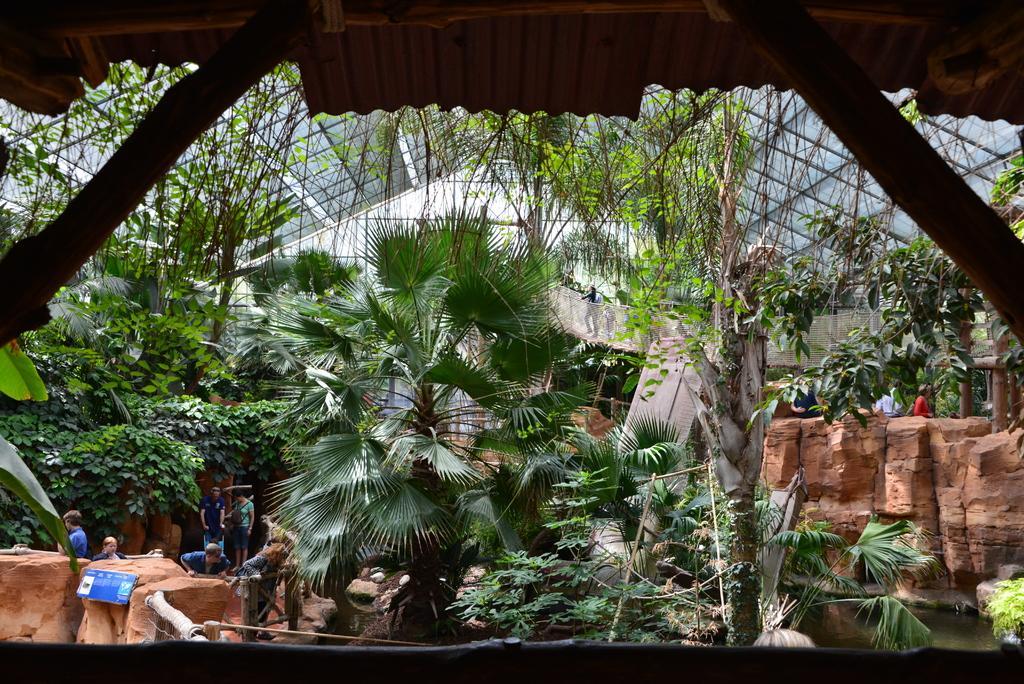Can you describe this image briefly? In this image, we can see some plants and trees, we can see the wall and water, there is a shed at the top, we can see some people standing. 